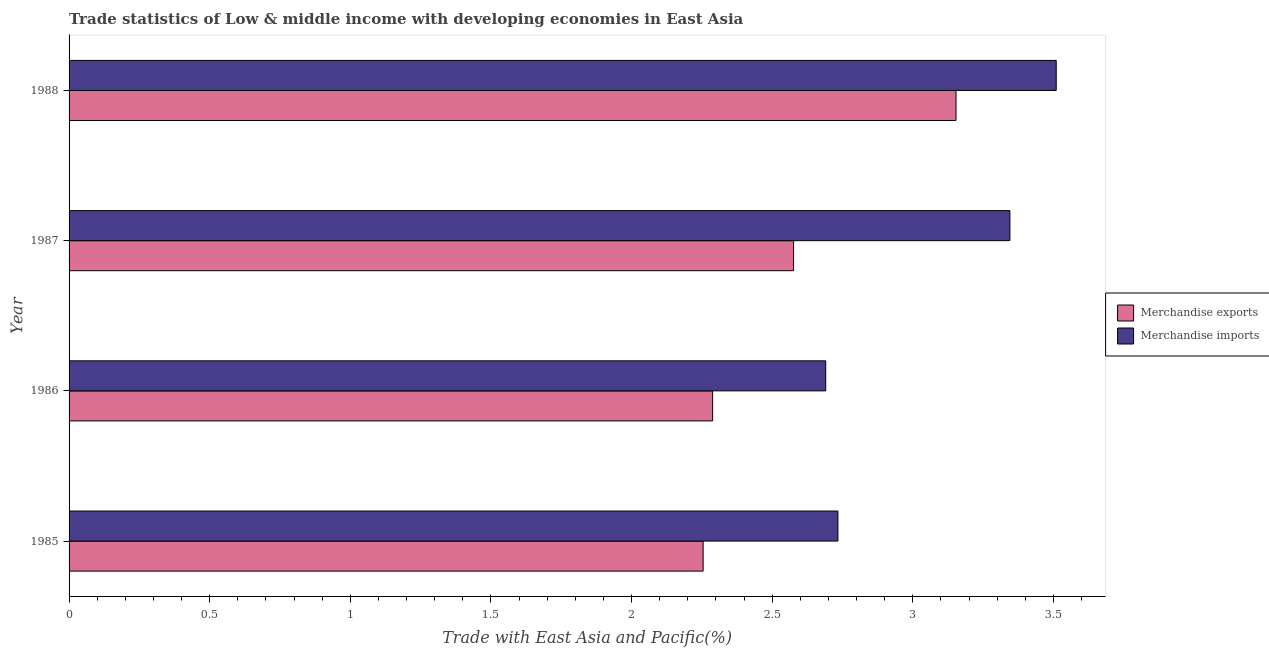How many groups of bars are there?
Ensure brevity in your answer.  4. How many bars are there on the 3rd tick from the top?
Your response must be concise. 2. What is the label of the 1st group of bars from the top?
Make the answer very short. 1988. In how many cases, is the number of bars for a given year not equal to the number of legend labels?
Make the answer very short. 0. What is the merchandise exports in 1986?
Make the answer very short. 2.29. Across all years, what is the maximum merchandise imports?
Ensure brevity in your answer.  3.51. Across all years, what is the minimum merchandise exports?
Your answer should be compact. 2.25. In which year was the merchandise exports maximum?
Provide a succinct answer. 1988. What is the total merchandise imports in the graph?
Your response must be concise. 12.28. What is the difference between the merchandise exports in 1985 and that in 1986?
Offer a terse response. -0.03. What is the difference between the merchandise exports in 1988 and the merchandise imports in 1986?
Offer a very short reply. 0.46. What is the average merchandise exports per year?
Your response must be concise. 2.57. In the year 1987, what is the difference between the merchandise exports and merchandise imports?
Make the answer very short. -0.77. In how many years, is the merchandise exports greater than 3.2 %?
Ensure brevity in your answer.  0. What is the difference between the highest and the second highest merchandise exports?
Provide a succinct answer. 0.58. What is the difference between the highest and the lowest merchandise imports?
Keep it short and to the point. 0.82. In how many years, is the merchandise imports greater than the average merchandise imports taken over all years?
Make the answer very short. 2. What does the 1st bar from the top in 1987 represents?
Offer a very short reply. Merchandise imports. What does the 1st bar from the bottom in 1988 represents?
Make the answer very short. Merchandise exports. How many bars are there?
Ensure brevity in your answer.  8. Are all the bars in the graph horizontal?
Your response must be concise. Yes. Does the graph contain any zero values?
Your answer should be compact. No. Does the graph contain grids?
Offer a terse response. No. How are the legend labels stacked?
Offer a terse response. Vertical. What is the title of the graph?
Your response must be concise. Trade statistics of Low & middle income with developing economies in East Asia. What is the label or title of the X-axis?
Make the answer very short. Trade with East Asia and Pacific(%). What is the Trade with East Asia and Pacific(%) of Merchandise exports in 1985?
Make the answer very short. 2.25. What is the Trade with East Asia and Pacific(%) of Merchandise imports in 1985?
Offer a very short reply. 2.73. What is the Trade with East Asia and Pacific(%) in Merchandise exports in 1986?
Your answer should be very brief. 2.29. What is the Trade with East Asia and Pacific(%) in Merchandise imports in 1986?
Offer a terse response. 2.69. What is the Trade with East Asia and Pacific(%) in Merchandise exports in 1987?
Your response must be concise. 2.58. What is the Trade with East Asia and Pacific(%) in Merchandise imports in 1987?
Offer a very short reply. 3.35. What is the Trade with East Asia and Pacific(%) of Merchandise exports in 1988?
Offer a very short reply. 3.15. What is the Trade with East Asia and Pacific(%) of Merchandise imports in 1988?
Offer a terse response. 3.51. Across all years, what is the maximum Trade with East Asia and Pacific(%) of Merchandise exports?
Make the answer very short. 3.15. Across all years, what is the maximum Trade with East Asia and Pacific(%) in Merchandise imports?
Make the answer very short. 3.51. Across all years, what is the minimum Trade with East Asia and Pacific(%) of Merchandise exports?
Provide a short and direct response. 2.25. Across all years, what is the minimum Trade with East Asia and Pacific(%) in Merchandise imports?
Provide a short and direct response. 2.69. What is the total Trade with East Asia and Pacific(%) of Merchandise exports in the graph?
Offer a very short reply. 10.27. What is the total Trade with East Asia and Pacific(%) in Merchandise imports in the graph?
Make the answer very short. 12.28. What is the difference between the Trade with East Asia and Pacific(%) in Merchandise exports in 1985 and that in 1986?
Ensure brevity in your answer.  -0.03. What is the difference between the Trade with East Asia and Pacific(%) in Merchandise imports in 1985 and that in 1986?
Provide a short and direct response. 0.04. What is the difference between the Trade with East Asia and Pacific(%) of Merchandise exports in 1985 and that in 1987?
Provide a short and direct response. -0.32. What is the difference between the Trade with East Asia and Pacific(%) of Merchandise imports in 1985 and that in 1987?
Provide a short and direct response. -0.61. What is the difference between the Trade with East Asia and Pacific(%) of Merchandise exports in 1985 and that in 1988?
Provide a succinct answer. -0.9. What is the difference between the Trade with East Asia and Pacific(%) of Merchandise imports in 1985 and that in 1988?
Your answer should be compact. -0.78. What is the difference between the Trade with East Asia and Pacific(%) of Merchandise exports in 1986 and that in 1987?
Give a very brief answer. -0.29. What is the difference between the Trade with East Asia and Pacific(%) in Merchandise imports in 1986 and that in 1987?
Keep it short and to the point. -0.65. What is the difference between the Trade with East Asia and Pacific(%) in Merchandise exports in 1986 and that in 1988?
Your response must be concise. -0.87. What is the difference between the Trade with East Asia and Pacific(%) in Merchandise imports in 1986 and that in 1988?
Offer a terse response. -0.82. What is the difference between the Trade with East Asia and Pacific(%) of Merchandise exports in 1987 and that in 1988?
Your response must be concise. -0.58. What is the difference between the Trade with East Asia and Pacific(%) of Merchandise imports in 1987 and that in 1988?
Offer a very short reply. -0.16. What is the difference between the Trade with East Asia and Pacific(%) in Merchandise exports in 1985 and the Trade with East Asia and Pacific(%) in Merchandise imports in 1986?
Make the answer very short. -0.44. What is the difference between the Trade with East Asia and Pacific(%) of Merchandise exports in 1985 and the Trade with East Asia and Pacific(%) of Merchandise imports in 1987?
Ensure brevity in your answer.  -1.09. What is the difference between the Trade with East Asia and Pacific(%) of Merchandise exports in 1985 and the Trade with East Asia and Pacific(%) of Merchandise imports in 1988?
Ensure brevity in your answer.  -1.26. What is the difference between the Trade with East Asia and Pacific(%) in Merchandise exports in 1986 and the Trade with East Asia and Pacific(%) in Merchandise imports in 1987?
Your response must be concise. -1.06. What is the difference between the Trade with East Asia and Pacific(%) of Merchandise exports in 1986 and the Trade with East Asia and Pacific(%) of Merchandise imports in 1988?
Provide a succinct answer. -1.22. What is the difference between the Trade with East Asia and Pacific(%) of Merchandise exports in 1987 and the Trade with East Asia and Pacific(%) of Merchandise imports in 1988?
Your response must be concise. -0.93. What is the average Trade with East Asia and Pacific(%) in Merchandise exports per year?
Offer a very short reply. 2.57. What is the average Trade with East Asia and Pacific(%) in Merchandise imports per year?
Offer a terse response. 3.07. In the year 1985, what is the difference between the Trade with East Asia and Pacific(%) of Merchandise exports and Trade with East Asia and Pacific(%) of Merchandise imports?
Ensure brevity in your answer.  -0.48. In the year 1986, what is the difference between the Trade with East Asia and Pacific(%) in Merchandise exports and Trade with East Asia and Pacific(%) in Merchandise imports?
Make the answer very short. -0.4. In the year 1987, what is the difference between the Trade with East Asia and Pacific(%) in Merchandise exports and Trade with East Asia and Pacific(%) in Merchandise imports?
Keep it short and to the point. -0.77. In the year 1988, what is the difference between the Trade with East Asia and Pacific(%) of Merchandise exports and Trade with East Asia and Pacific(%) of Merchandise imports?
Your answer should be compact. -0.36. What is the ratio of the Trade with East Asia and Pacific(%) of Merchandise exports in 1985 to that in 1986?
Offer a terse response. 0.99. What is the ratio of the Trade with East Asia and Pacific(%) of Merchandise imports in 1985 to that in 1986?
Provide a short and direct response. 1.02. What is the ratio of the Trade with East Asia and Pacific(%) in Merchandise exports in 1985 to that in 1987?
Offer a very short reply. 0.88. What is the ratio of the Trade with East Asia and Pacific(%) in Merchandise imports in 1985 to that in 1987?
Keep it short and to the point. 0.82. What is the ratio of the Trade with East Asia and Pacific(%) in Merchandise exports in 1985 to that in 1988?
Provide a succinct answer. 0.71. What is the ratio of the Trade with East Asia and Pacific(%) of Merchandise imports in 1985 to that in 1988?
Your answer should be very brief. 0.78. What is the ratio of the Trade with East Asia and Pacific(%) in Merchandise exports in 1986 to that in 1987?
Offer a terse response. 0.89. What is the ratio of the Trade with East Asia and Pacific(%) in Merchandise imports in 1986 to that in 1987?
Your response must be concise. 0.8. What is the ratio of the Trade with East Asia and Pacific(%) of Merchandise exports in 1986 to that in 1988?
Provide a short and direct response. 0.73. What is the ratio of the Trade with East Asia and Pacific(%) of Merchandise imports in 1986 to that in 1988?
Your answer should be very brief. 0.77. What is the ratio of the Trade with East Asia and Pacific(%) in Merchandise exports in 1987 to that in 1988?
Keep it short and to the point. 0.82. What is the ratio of the Trade with East Asia and Pacific(%) of Merchandise imports in 1987 to that in 1988?
Provide a short and direct response. 0.95. What is the difference between the highest and the second highest Trade with East Asia and Pacific(%) in Merchandise exports?
Keep it short and to the point. 0.58. What is the difference between the highest and the second highest Trade with East Asia and Pacific(%) in Merchandise imports?
Offer a very short reply. 0.16. What is the difference between the highest and the lowest Trade with East Asia and Pacific(%) in Merchandise exports?
Your response must be concise. 0.9. What is the difference between the highest and the lowest Trade with East Asia and Pacific(%) in Merchandise imports?
Ensure brevity in your answer.  0.82. 